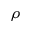Convert formula to latex. <formula><loc_0><loc_0><loc_500><loc_500>\rho</formula> 